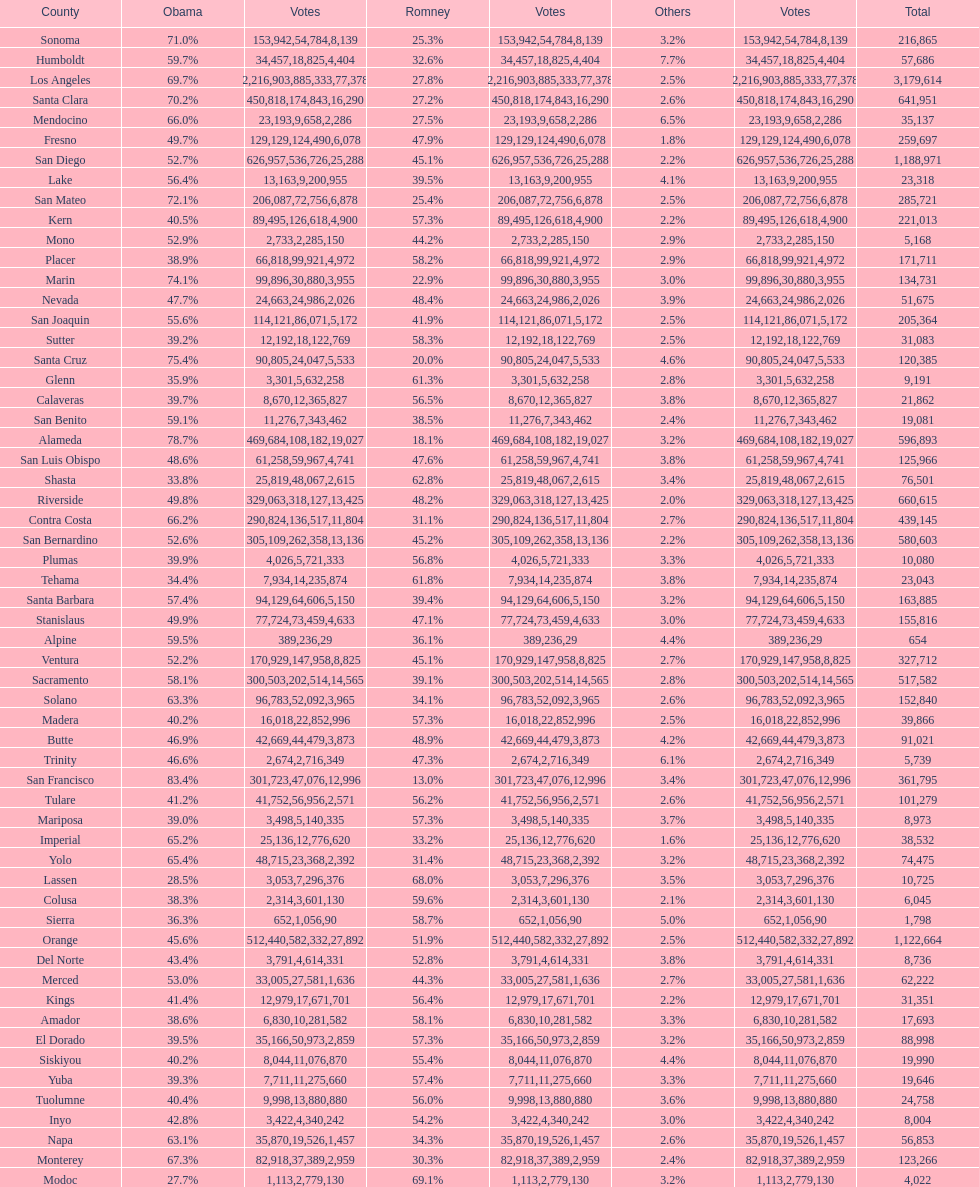What county is just before del norte on the list? Contra Costa. 